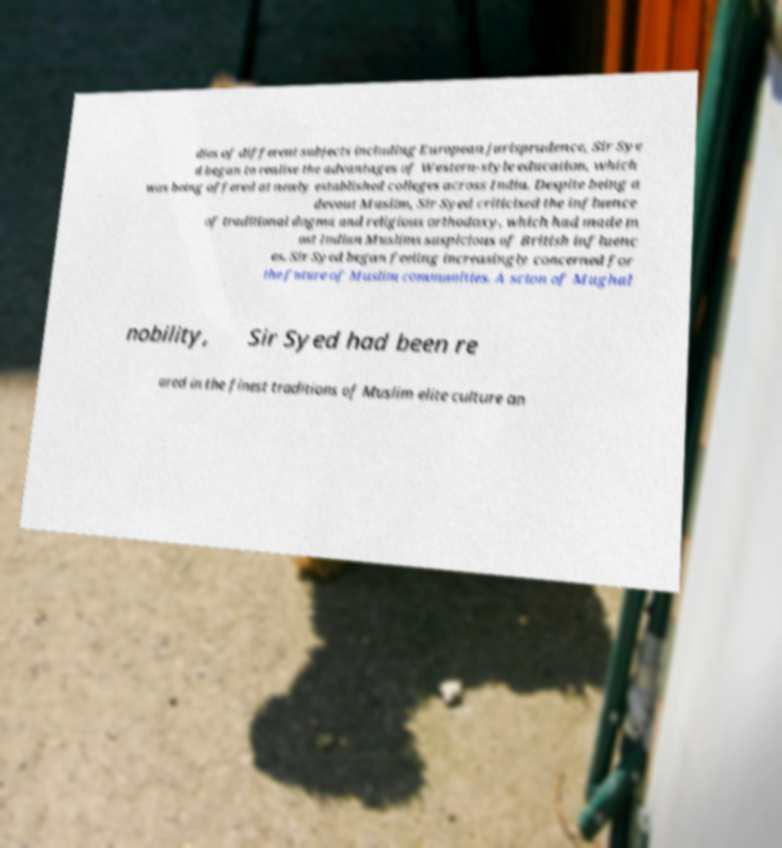For documentation purposes, I need the text within this image transcribed. Could you provide that? dies of different subjects including European jurisprudence, Sir Sye d began to realise the advantages of Western-style education, which was being offered at newly established colleges across India. Despite being a devout Muslim, Sir Syed criticised the influence of traditional dogma and religious orthodoxy, which had made m ost Indian Muslims suspicious of British influenc es. Sir Syed began feeling increasingly concerned for the future of Muslim communities. A scion of Mughal nobility, Sir Syed had been re ared in the finest traditions of Muslim elite culture an 